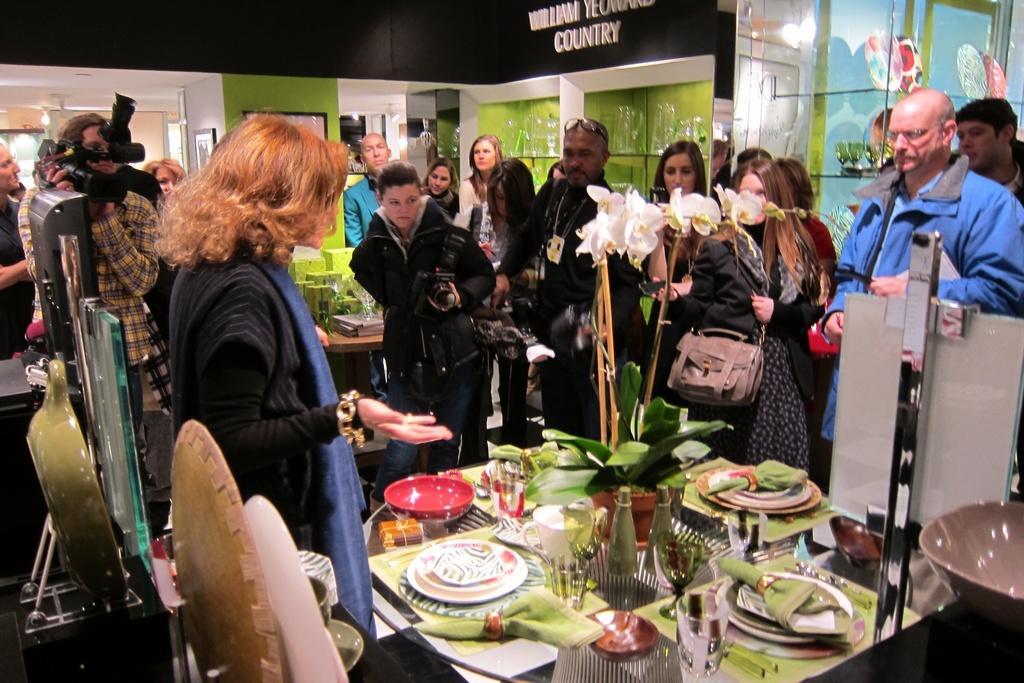Can you describe this image briefly? In this picture there is a group of men and women standing near the dining table. In the middle there is a woman wearing a black jacket taking the photos with camera. In the front there is a dining table we flower pot, white plates, glass and green cloth. In the background there is a green color wall and shelves. 